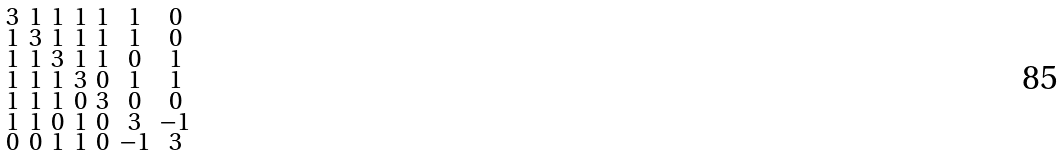Convert formula to latex. <formula><loc_0><loc_0><loc_500><loc_500>\begin{smallmatrix} 3 & 1 & 1 & 1 & 1 & 1 & 0 \\ 1 & 3 & 1 & 1 & 1 & 1 & 0 \\ 1 & 1 & 3 & 1 & 1 & 0 & 1 \\ 1 & 1 & 1 & 3 & 0 & 1 & 1 \\ 1 & 1 & 1 & 0 & 3 & 0 & 0 \\ 1 & 1 & 0 & 1 & 0 & 3 & - 1 \\ 0 & 0 & 1 & 1 & 0 & - 1 & 3 \end{smallmatrix}</formula> 